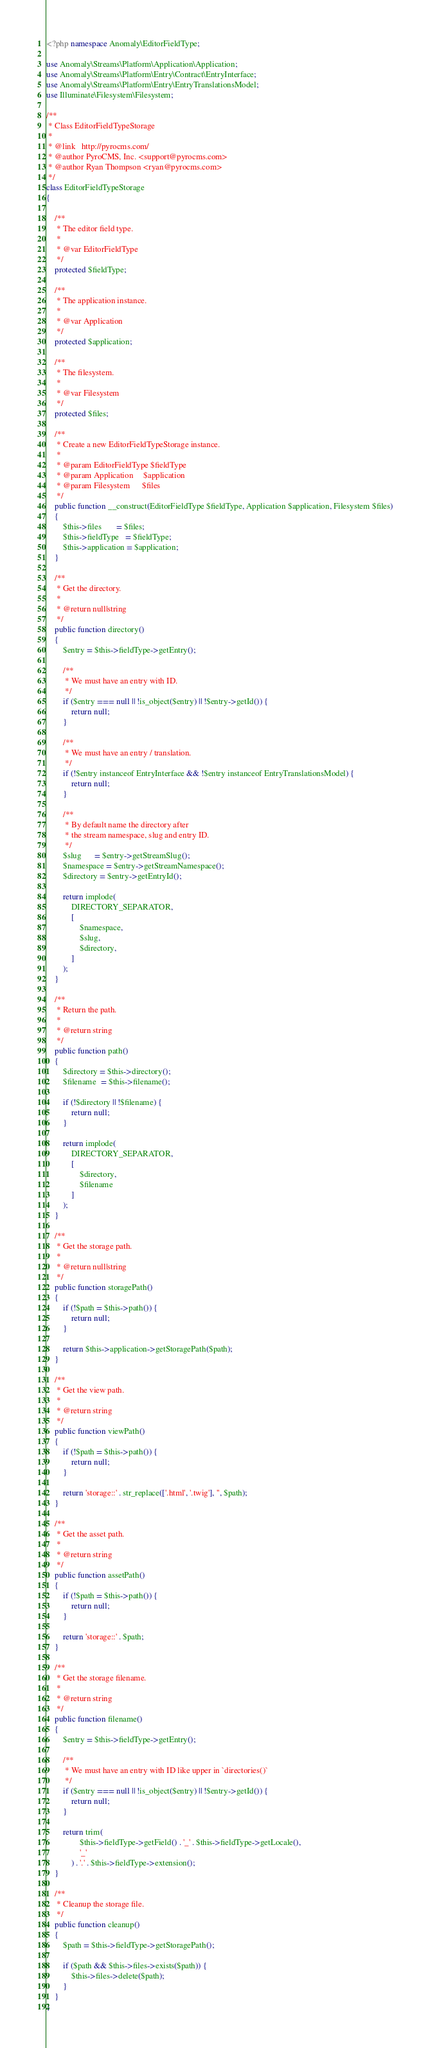Convert code to text. <code><loc_0><loc_0><loc_500><loc_500><_PHP_><?php namespace Anomaly\EditorFieldType;

use Anomaly\Streams\Platform\Application\Application;
use Anomaly\Streams\Platform\Entry\Contract\EntryInterface;
use Anomaly\Streams\Platform\Entry\EntryTranslationsModel;
use Illuminate\Filesystem\Filesystem;

/**
 * Class EditorFieldTypeStorage
 *
 * @link   http://pyrocms.com/
 * @author PyroCMS, Inc. <support@pyrocms.com>
 * @author Ryan Thompson <ryan@pyrocms.com>
 */
class EditorFieldTypeStorage
{

    /**
     * The editor field type.
     *
     * @var EditorFieldType
     */
    protected $fieldType;

    /**
     * The application instance.
     *
     * @var Application
     */
    protected $application;

    /**
     * The filesystem.
     *
     * @var Filesystem
     */
    protected $files;

    /**
     * Create a new EditorFieldTypeStorage instance.
     *
     * @param EditorFieldType $fieldType
     * @param Application     $application
     * @param Filesystem      $files
     */
    public function __construct(EditorFieldType $fieldType, Application $application, Filesystem $files)
    {
        $this->files       = $files;
        $this->fieldType   = $fieldType;
        $this->application = $application;
    }

    /**
     * Get the directory.
     *
     * @return null|string
     */
    public function directory()
    {
        $entry = $this->fieldType->getEntry();

        /**
         * We must have an entry with ID.
         */
        if ($entry === null || !is_object($entry) || !$entry->getId()) {
            return null;
        }

        /**
         * We must have an entry / translation.
         */
        if (!$entry instanceof EntryInterface && !$entry instanceof EntryTranslationsModel) {
            return null;
        }

        /**
         * By default name the directory after
         * the stream namespace, slug and entry ID.
         */
        $slug      = $entry->getStreamSlug();
        $namespace = $entry->getStreamNamespace();
        $directory = $entry->getEntryId();

        return implode(
            DIRECTORY_SEPARATOR,
            [
                $namespace,
                $slug,
                $directory,
            ]
        );
    }

    /**
     * Return the path.
     *
     * @return string
     */
    public function path()
    {
        $directory = $this->directory();
        $filename  = $this->filename();

        if (!$directory || !$filename) {
            return null;
        }

        return implode(
            DIRECTORY_SEPARATOR,
            [
                $directory,
                $filename
            ]
        );
    }

    /**
     * Get the storage path.
     *
     * @return null|string
     */
    public function storagePath()
    {
        if (!$path = $this->path()) {
            return null;
        }

        return $this->application->getStoragePath($path);
    }

    /**
     * Get the view path.
     *
     * @return string
     */
    public function viewPath()
    {
        if (!$path = $this->path()) {
            return null;
        }

        return 'storage::' . str_replace(['.html', '.twig'], '', $path);
    }

    /**
     * Get the asset path.
     *
     * @return string
     */
    public function assetPath()
    {
        if (!$path = $this->path()) {
            return null;
        }

        return 'storage::' . $path;
    }

    /**
     * Get the storage filename.
     *
     * @return string
     */
    public function filename()
    {
        $entry = $this->fieldType->getEntry();

        /**
         * We must have an entry with ID like upper in `directories()`
         */
        if ($entry === null || !is_object($entry) || !$entry->getId()) {
            return null;
        }

        return trim(
                $this->fieldType->getField() . '_' . $this->fieldType->getLocale(),
                '_'
            ) . '.' . $this->fieldType->extension();
    }

    /**
     * Cleanup the storage file.
     */
    public function cleanup()
    {
        $path = $this->fieldType->getStoragePath();

        if ($path && $this->files->exists($path)) {
            $this->files->delete($path);
        }
    }
}
</code> 